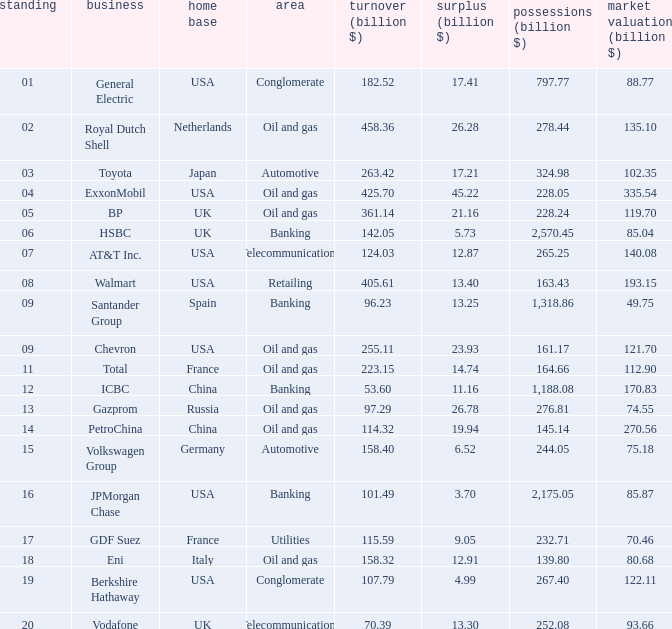How many Assets (billion $) has an Industry of oil and gas, and a Rank of 9, and a Market Value (billion $) larger than 121.7? None. 